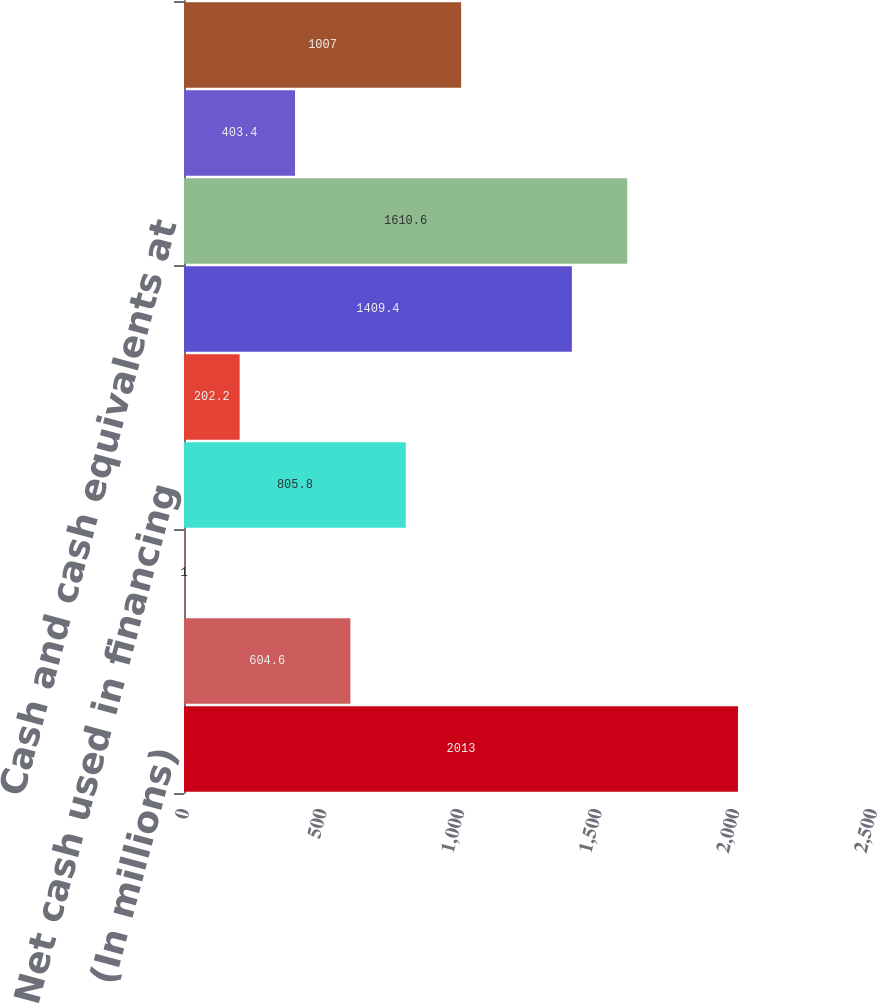Convert chart. <chart><loc_0><loc_0><loc_500><loc_500><bar_chart><fcel>(In millions)<fcel>Excess tax benefit from<fcel>Other<fcel>Net cash used in financing<fcel>Effect of exchange rates on<fcel>Net increase (decrease) in<fcel>Cash and cash equivalents at<fcel>Interest paid<fcel>Income taxes paid<nl><fcel>2013<fcel>604.6<fcel>1<fcel>805.8<fcel>202.2<fcel>1409.4<fcel>1610.6<fcel>403.4<fcel>1007<nl></chart> 